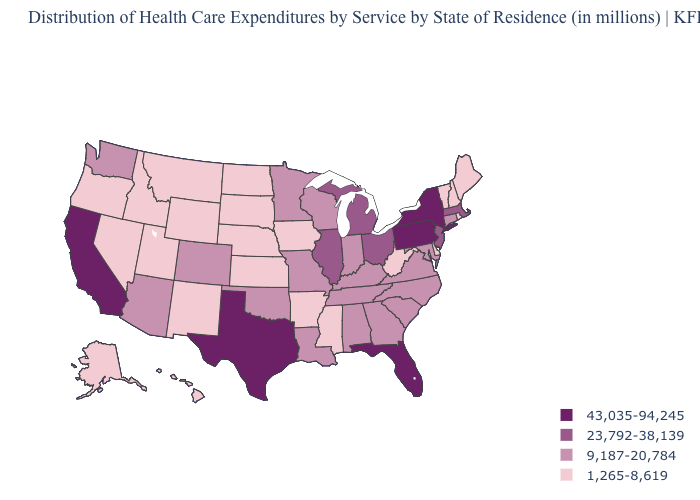What is the highest value in states that border Idaho?
Quick response, please. 9,187-20,784. Among the states that border Utah , which have the highest value?
Be succinct. Arizona, Colorado. What is the value of Rhode Island?
Keep it brief. 1,265-8,619. What is the highest value in the South ?
Keep it brief. 43,035-94,245. Name the states that have a value in the range 1,265-8,619?
Answer briefly. Alaska, Arkansas, Delaware, Hawaii, Idaho, Iowa, Kansas, Maine, Mississippi, Montana, Nebraska, Nevada, New Hampshire, New Mexico, North Dakota, Oregon, Rhode Island, South Dakota, Utah, Vermont, West Virginia, Wyoming. Name the states that have a value in the range 43,035-94,245?
Concise answer only. California, Florida, New York, Pennsylvania, Texas. What is the value of Pennsylvania?
Concise answer only. 43,035-94,245. Does Idaho have the highest value in the USA?
Short answer required. No. Which states have the highest value in the USA?
Be succinct. California, Florida, New York, Pennsylvania, Texas. Does Wisconsin have a lower value than Missouri?
Quick response, please. No. Name the states that have a value in the range 1,265-8,619?
Give a very brief answer. Alaska, Arkansas, Delaware, Hawaii, Idaho, Iowa, Kansas, Maine, Mississippi, Montana, Nebraska, Nevada, New Hampshire, New Mexico, North Dakota, Oregon, Rhode Island, South Dakota, Utah, Vermont, West Virginia, Wyoming. What is the value of Iowa?
Concise answer only. 1,265-8,619. 